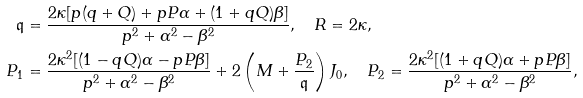<formula> <loc_0><loc_0><loc_500><loc_500>\mathfrak { q } & = \frac { 2 \kappa [ p ( q + Q ) + p P \alpha + ( 1 + q Q ) \beta ] } { p ^ { 2 } + \alpha ^ { 2 } - \beta ^ { 2 } } , \quad R = 2 \kappa , \\ P _ { 1 } & = \frac { 2 \kappa ^ { 2 } [ ( 1 - q Q ) \alpha - p P \beta ] } { p ^ { 2 } + \alpha ^ { 2 } - \beta ^ { 2 } } + 2 \left ( M + \frac { P _ { 2 } } { \mathfrak { q } } \right ) J _ { 0 } , \quad P _ { 2 } = \frac { 2 \kappa ^ { 2 } [ ( 1 + q Q ) \alpha + p P \beta ] } { p ^ { 2 } + \alpha ^ { 2 } - \beta ^ { 2 } } ,</formula> 